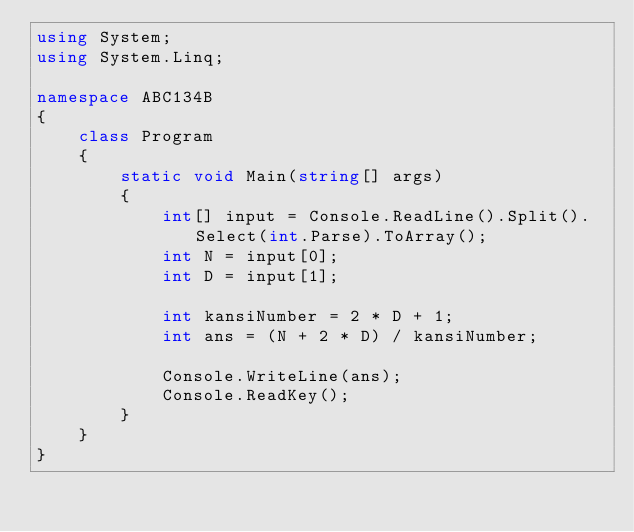Convert code to text. <code><loc_0><loc_0><loc_500><loc_500><_C#_>using System;
using System.Linq;

namespace ABC134B
{
    class Program
    {
        static void Main(string[] args)
        {
            int[] input = Console.ReadLine().Split().Select(int.Parse).ToArray();
            int N = input[0];
            int D = input[1];

            int kansiNumber = 2 * D + 1;
            int ans = (N + 2 * D) / kansiNumber;

            Console.WriteLine(ans);
            Console.ReadKey();
        }
    }
}
</code> 